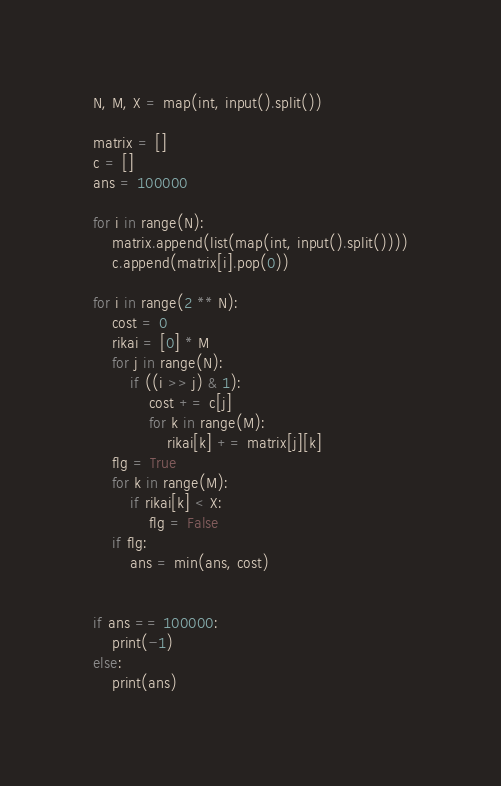<code> <loc_0><loc_0><loc_500><loc_500><_Python_>N, M, X = map(int, input().split())

matrix = []
c = []
ans = 100000

for i in range(N):
    matrix.append(list(map(int, input().split())))
    c.append(matrix[i].pop(0))

for i in range(2 ** N):
    cost = 0
    rikai = [0] * M
    for j in range(N):
        if ((i >> j) & 1):
            cost += c[j]
            for k in range(M):
                rikai[k] += matrix[j][k]
    flg = True
    for k in range(M):
        if rikai[k] < X:
            flg = False
    if flg:
        ans = min(ans, cost)
    

if ans == 100000:
    print(-1)
else:
    print(ans)        
</code> 